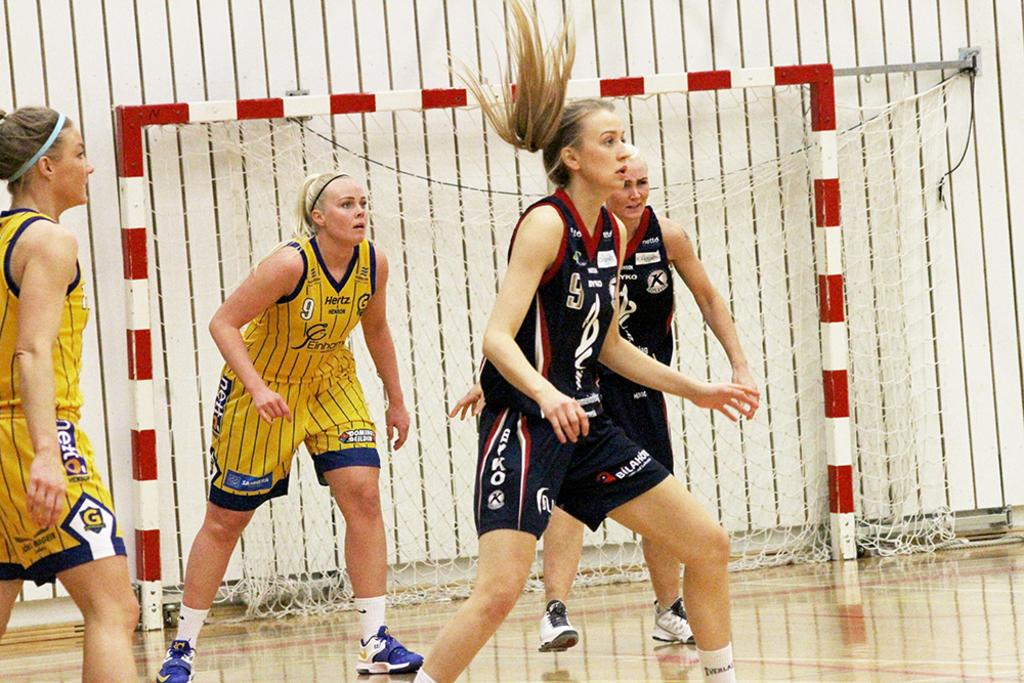What are the women in the image doing? The women are playing in the image. What can be seen in the background of the image? There is a net and a wall in the background of the image. What is the color and design of the stand in the image? The stand in the image is red and white. What type of guide is present in the image? There is no guide present in the image. Can you describe the farmer in the image? There is no farmer present in the image. 